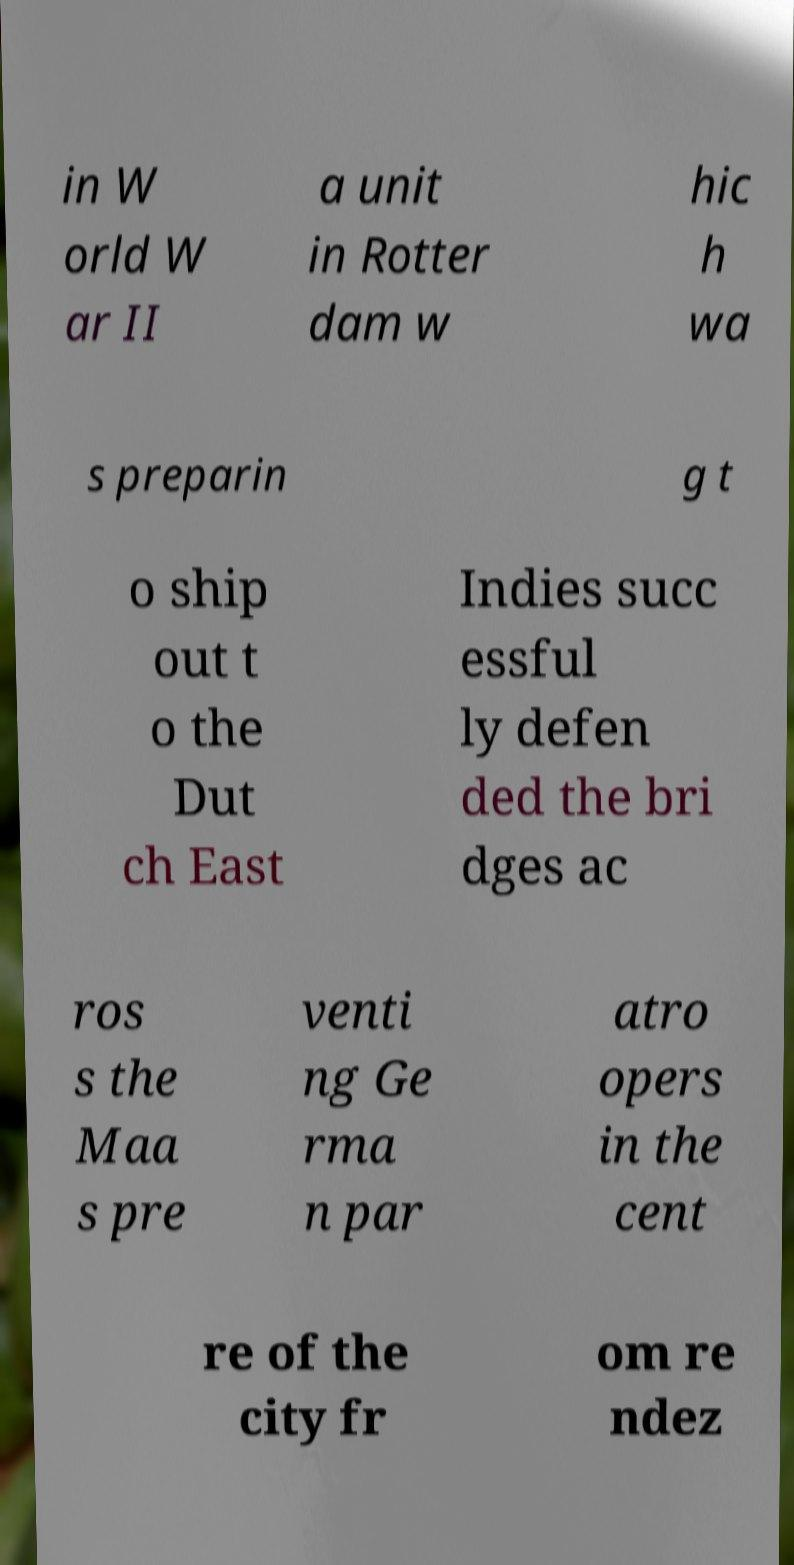For documentation purposes, I need the text within this image transcribed. Could you provide that? in W orld W ar II a unit in Rotter dam w hic h wa s preparin g t o ship out t o the Dut ch East Indies succ essful ly defen ded the bri dges ac ros s the Maa s pre venti ng Ge rma n par atro opers in the cent re of the city fr om re ndez 